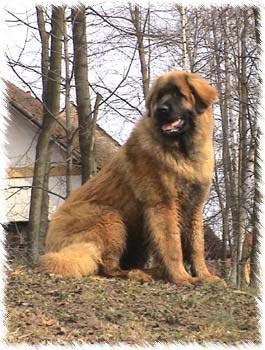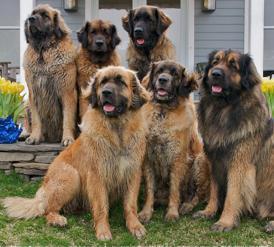The first image is the image on the left, the second image is the image on the right. For the images displayed, is the sentence "There are at most three dogs." factually correct? Answer yes or no. No. The first image is the image on the left, the second image is the image on the right. Examine the images to the left and right. Is the description "In one image there are multiple dogs sitting outside." accurate? Answer yes or no. Yes. 